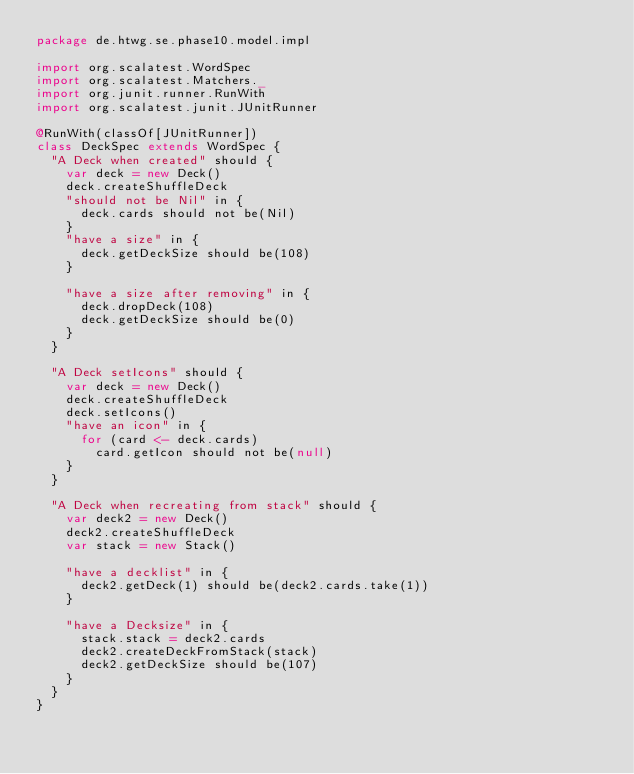<code> <loc_0><loc_0><loc_500><loc_500><_Scala_>package de.htwg.se.phase10.model.impl

import org.scalatest.WordSpec
import org.scalatest.Matchers._
import org.junit.runner.RunWith
import org.scalatest.junit.JUnitRunner

@RunWith(classOf[JUnitRunner])
class DeckSpec extends WordSpec {
  "A Deck when created" should {
    var deck = new Deck()
    deck.createShuffleDeck
    "should not be Nil" in {
      deck.cards should not be(Nil) 
    }
    "have a size" in {
      deck.getDeckSize should be(108)
    }
    
    "have a size after removing" in {
      deck.dropDeck(108)
      deck.getDeckSize should be(0)
    }
  }
  
  "A Deck setIcons" should {
    var deck = new Deck()
    deck.createShuffleDeck
    deck.setIcons()
    "have an icon" in {
      for (card <- deck.cards)
        card.getIcon should not be(null)
    }
  }
  
  "A Deck when recreating from stack" should {
    var deck2 = new Deck()
    deck2.createShuffleDeck
    var stack = new Stack()
    
    "have a decklist" in {
      deck2.getDeck(1) should be(deck2.cards.take(1))
    }
    
    "have a Decksize" in {
      stack.stack = deck2.cards
      deck2.createDeckFromStack(stack)
      deck2.getDeckSize should be(107)
    }
  }
}
          </code> 